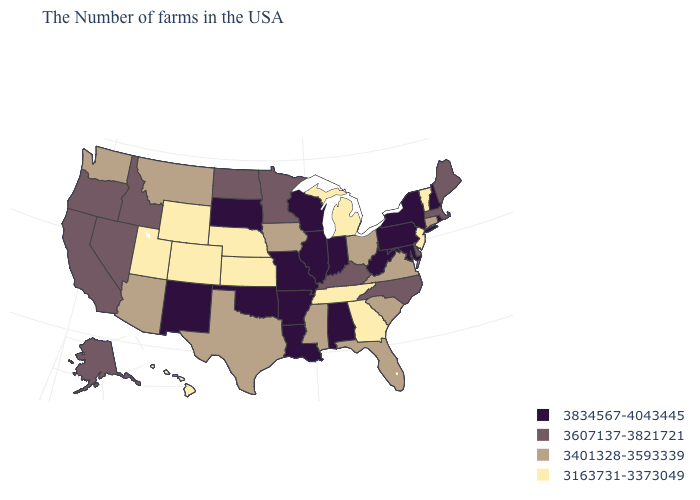Does the map have missing data?
Answer briefly. No. Name the states that have a value in the range 3163731-3373049?
Keep it brief. Vermont, New Jersey, Georgia, Michigan, Tennessee, Kansas, Nebraska, Wyoming, Colorado, Utah, Hawaii. What is the highest value in states that border Texas?
Keep it brief. 3834567-4043445. Which states hav the highest value in the MidWest?
Be succinct. Indiana, Wisconsin, Illinois, Missouri, South Dakota. Name the states that have a value in the range 3607137-3821721?
Concise answer only. Maine, Massachusetts, Delaware, North Carolina, Kentucky, Minnesota, North Dakota, Idaho, Nevada, California, Oregon, Alaska. Is the legend a continuous bar?
Be succinct. No. What is the value of North Carolina?
Keep it brief. 3607137-3821721. Does the map have missing data?
Write a very short answer. No. Name the states that have a value in the range 3834567-4043445?
Keep it brief. Rhode Island, New Hampshire, New York, Maryland, Pennsylvania, West Virginia, Indiana, Alabama, Wisconsin, Illinois, Louisiana, Missouri, Arkansas, Oklahoma, South Dakota, New Mexico. Name the states that have a value in the range 3163731-3373049?
Quick response, please. Vermont, New Jersey, Georgia, Michigan, Tennessee, Kansas, Nebraska, Wyoming, Colorado, Utah, Hawaii. Name the states that have a value in the range 3401328-3593339?
Give a very brief answer. Connecticut, Virginia, South Carolina, Ohio, Florida, Mississippi, Iowa, Texas, Montana, Arizona, Washington. What is the value of Wisconsin?
Concise answer only. 3834567-4043445. What is the lowest value in the West?
Quick response, please. 3163731-3373049. Does Kansas have a lower value than Nevada?
Answer briefly. Yes. 